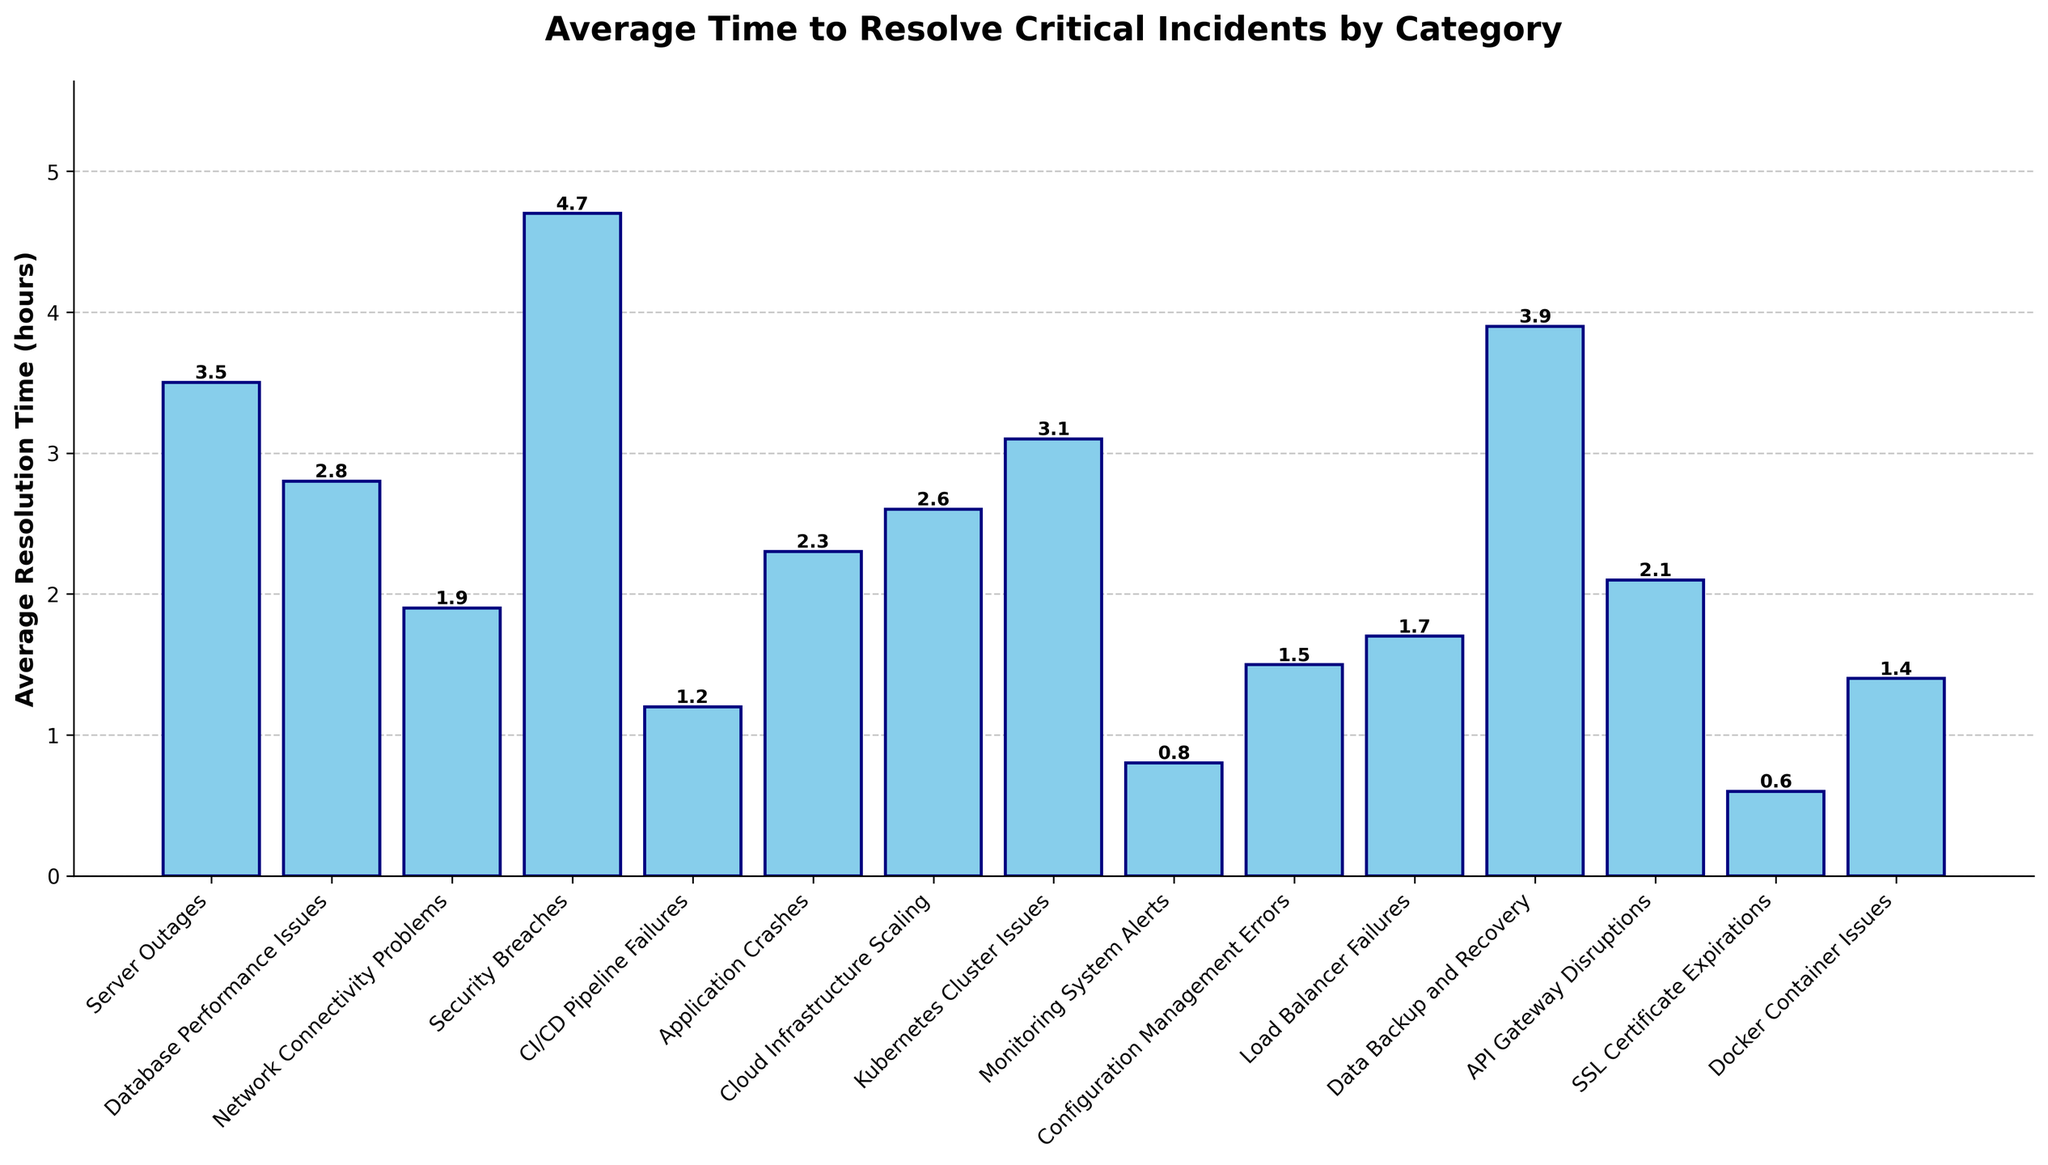What category has the highest average resolution time? The bar representing the highest value is for Security Breaches, which has the tallest bar.
Answer: Security Breaches What category has the lowest average resolution time? The bar representing the lowest value is for SSL Certificate Expirations, which has the shortest bar.
Answer: SSL Certificate Expirations Which two categories have the closest average resolution times? The bars for Docker Container Issues and Configuration Management Errors have similar heights.
Answer: Docker Container Issues and Configuration Management Errors By how much does the average resolution time for Security Breaches exceed the average resolution time for Network Connectivity Problems? The average resolution time for Security Breaches is 4.7 hours, and for Network Connectivity Problems, it is 1.9 hours. The difference is calculated as 4.7 - 1.9 = 2.8 hours.
Answer: 2.8 hours What's the combined average resolution time for Server Outages and Data Backup and Recovery? The sum of the average resolution times for Server Outages (3.5 hours) and Data Backup and Recovery (3.9 hours) is 3.5 + 3.9 = 7.4 hours.
Answer: 7.4 hours List the categories that have an average resolution time less than 2 hours. The categories with average resolution times less than 2 hours are Network Connectivity Problems (1.9 hours), CI/CD Pipeline Failures (1.2 hours), Monitoring System Alerts (0.8 hours), Configuration Management Errors (1.5 hours), Load Balancer Failures (1.7 hours), SSL Certificate Expirations (0.6 hours), Docker Container Issues (1.4 hours).
Answer: Network Connectivity Problems, CI/CD Pipeline Failures, Monitoring System Alerts, Configuration Management Errors, Load Balancer Failures, SSL Certificate Expirations, Docker Container Issues How many categories have an average resolution time greater than 3 hours? The categories with average resolution times greater than 3 hours are Server Outages (3.5 hours), Security Breaches (4.7 hours), Data Backup and Recovery (3.9 hours), Kubernetes Cluster Issues (3.1 hours). There are 4 such categories.
Answer: 4 Which category has an average resolution time that is exactly double that of Docker Container Issues? The average resolution time for Docker Container Issues is 1.4 hours, so double this time is 1.4 * 2 = 2.8 hours. The category with an average resolution time of 2.8 hours is Database Performance Issues.
Answer: Database Performance Issues What is the difference between the average resolution time for Cloud Infrastructure Scaling and Application Crashes? The average resolution time for Cloud Infrastructure Scaling is 2.6 hours, and for Application Crashes, it is 2.3 hours. The difference is calculated as 2.6 - 2.3 = 0.3 hours.
Answer: 0.3 hours 